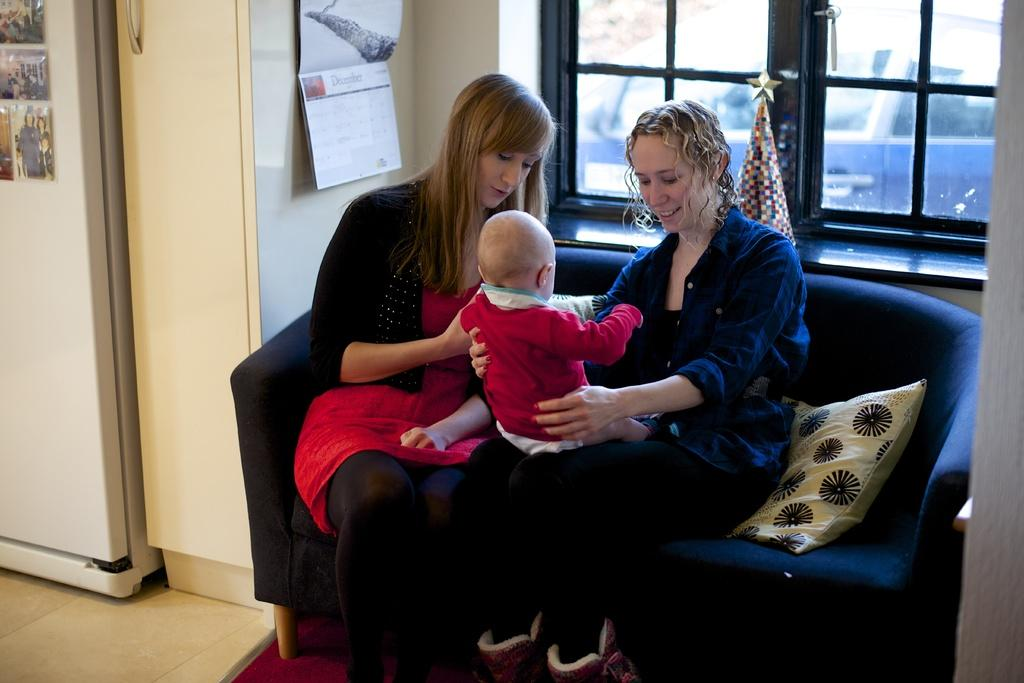How many people are in the image? There are two women in the image. What is one of the women doing in the image? One of the women is holding a baby. What can be seen on the wall in the image? There are windows visible in the image. Where are the windows located on the wall? The windows are on a wall. What type of design is requested by the children in the image? There are no children present in the image, and therefore no design request can be observed. 